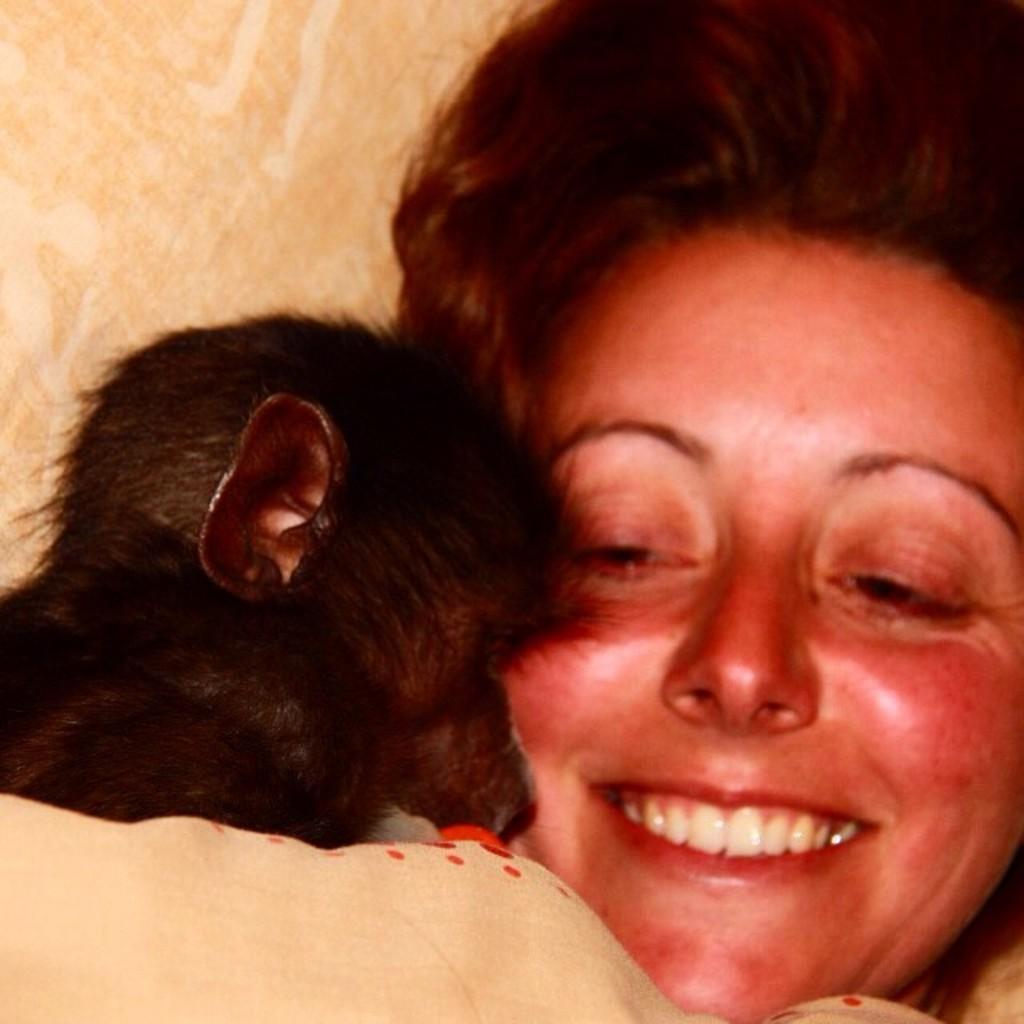In one or two sentences, can you explain what this image depicts? In this image, at the right side there is a woman, she is smiling, at the left side there is a black color animal. 